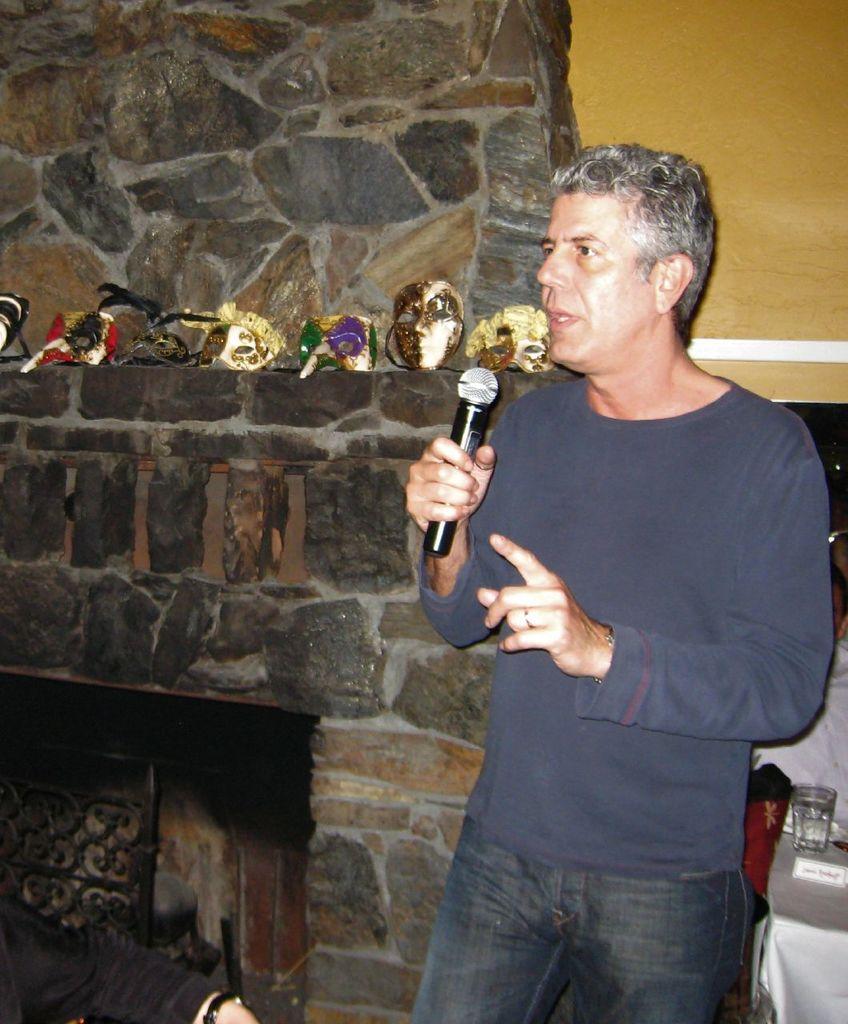Please provide a concise description of this image. In this picture there is a man standing and talking and he is holding the microphone. At the back there are objects on the wall. On the right side of the image there is a glass and there is a board on the table. At the bottom left there is a person sitting. 